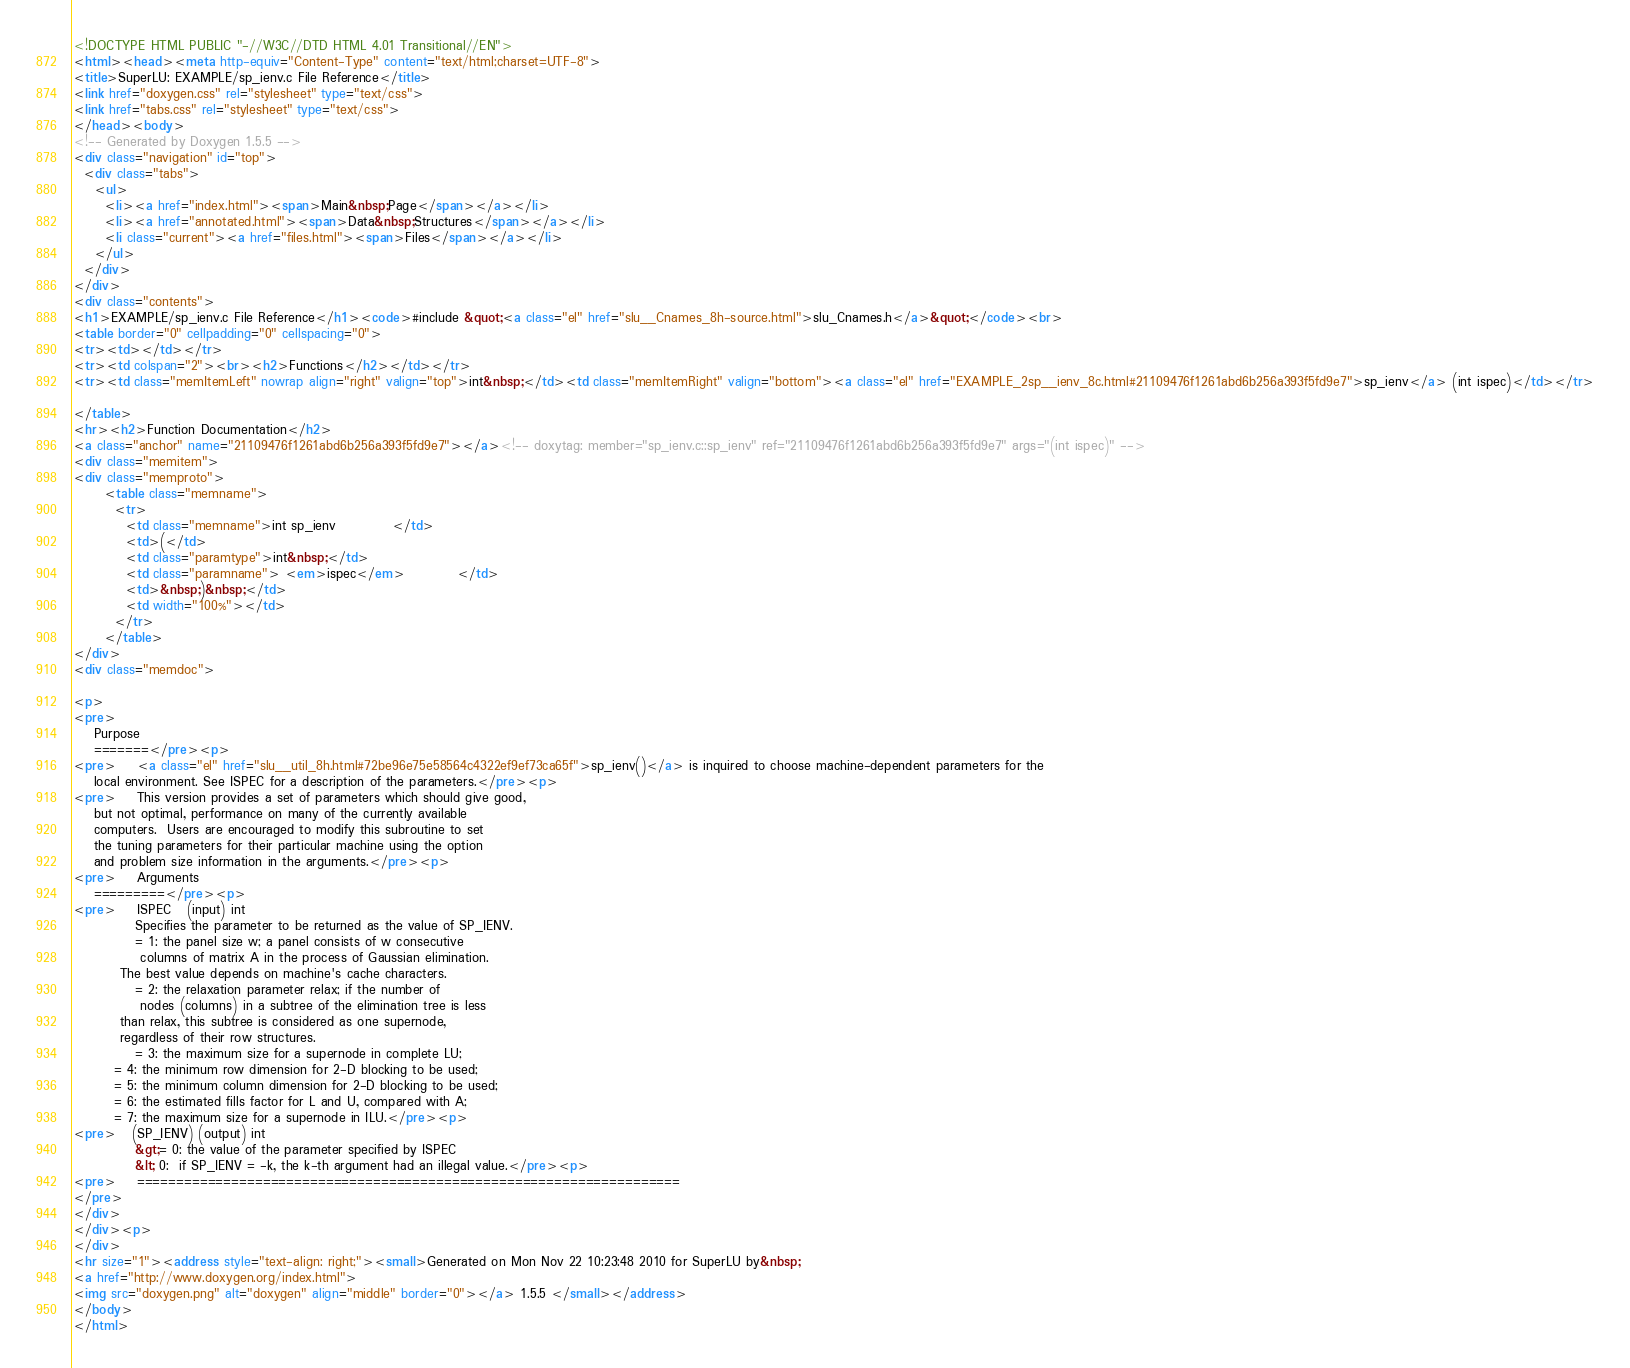<code> <loc_0><loc_0><loc_500><loc_500><_HTML_><!DOCTYPE HTML PUBLIC "-//W3C//DTD HTML 4.01 Transitional//EN">
<html><head><meta http-equiv="Content-Type" content="text/html;charset=UTF-8">
<title>SuperLU: EXAMPLE/sp_ienv.c File Reference</title>
<link href="doxygen.css" rel="stylesheet" type="text/css">
<link href="tabs.css" rel="stylesheet" type="text/css">
</head><body>
<!-- Generated by Doxygen 1.5.5 -->
<div class="navigation" id="top">
  <div class="tabs">
    <ul>
      <li><a href="index.html"><span>Main&nbsp;Page</span></a></li>
      <li><a href="annotated.html"><span>Data&nbsp;Structures</span></a></li>
      <li class="current"><a href="files.html"><span>Files</span></a></li>
    </ul>
  </div>
</div>
<div class="contents">
<h1>EXAMPLE/sp_ienv.c File Reference</h1><code>#include &quot;<a class="el" href="slu__Cnames_8h-source.html">slu_Cnames.h</a>&quot;</code><br>
<table border="0" cellpadding="0" cellspacing="0">
<tr><td></td></tr>
<tr><td colspan="2"><br><h2>Functions</h2></td></tr>
<tr><td class="memItemLeft" nowrap align="right" valign="top">int&nbsp;</td><td class="memItemRight" valign="bottom"><a class="el" href="EXAMPLE_2sp__ienv_8c.html#21109476f1261abd6b256a393f5fd9e7">sp_ienv</a> (int ispec)</td></tr>

</table>
<hr><h2>Function Documentation</h2>
<a class="anchor" name="21109476f1261abd6b256a393f5fd9e7"></a><!-- doxytag: member="sp_ienv.c::sp_ienv" ref="21109476f1261abd6b256a393f5fd9e7" args="(int ispec)" -->
<div class="memitem">
<div class="memproto">
      <table class="memname">
        <tr>
          <td class="memname">int sp_ienv           </td>
          <td>(</td>
          <td class="paramtype">int&nbsp;</td>
          <td class="paramname"> <em>ispec</em>          </td>
          <td>&nbsp;)&nbsp;</td>
          <td width="100%"></td>
        </tr>
      </table>
</div>
<div class="memdoc">

<p>
<pre>
    Purpose   
    =======</pre><p>
<pre>    <a class="el" href="slu__util_8h.html#72be96e75e58564c4322ef9ef73ca65f">sp_ienv()</a> is inquired to choose machine-dependent parameters for the
    local environment. See ISPEC for a description of the parameters.</pre><p>
<pre>    This version provides a set of parameters which should give good,   
    but not optimal, performance on many of the currently available   
    computers.  Users are encouraged to modify this subroutine to set   
    the tuning parameters for their particular machine using the option   
    and problem size information in the arguments.</pre><p>
<pre>    Arguments   
    =========</pre><p>
<pre>    ISPEC   (input) int
            Specifies the parameter to be returned as the value of SP_IENV.   
            = 1: the panel size w; a panel consists of w consecutive
	         columns of matrix A in the process of Gaussian elimination.
		 The best value depends on machine's cache characters.
            = 2: the relaxation parameter relax; if the number of
	         nodes (columns) in a subtree of the elimination tree is less
		 than relax, this subtree is considered as one supernode,
		 regardless of their row structures.
            = 3: the maximum size for a supernode in complete LU;
	    = 4: the minimum row dimension for 2-D blocking to be used;
	    = 5: the minimum column dimension for 2-D blocking to be used;
	    = 6: the estimated fills factor for L and U, compared with A;
	    = 7: the maximum size for a supernode in ILU.</pre><p>
<pre>   (SP_IENV) (output) int
            &gt;= 0: the value of the parameter specified by ISPEC   
            &lt; 0:  if SP_IENV = -k, the k-th argument had an illegal value.</pre><p>
<pre>    ===================================================================== 
</pre> 
</div>
</div><p>
</div>
<hr size="1"><address style="text-align: right;"><small>Generated on Mon Nov 22 10:23:48 2010 for SuperLU by&nbsp;
<a href="http://www.doxygen.org/index.html">
<img src="doxygen.png" alt="doxygen" align="middle" border="0"></a> 1.5.5 </small></address>
</body>
</html>
</code> 